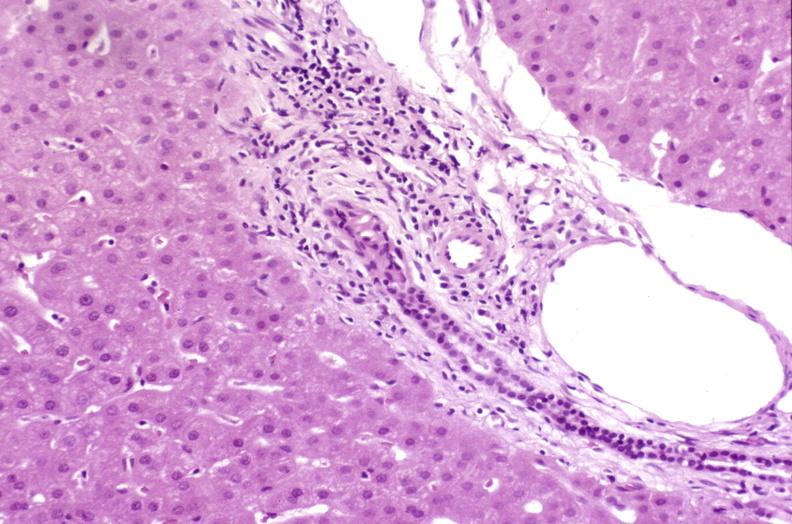s antitrypsin present?
Answer the question using a single word or phrase. No 